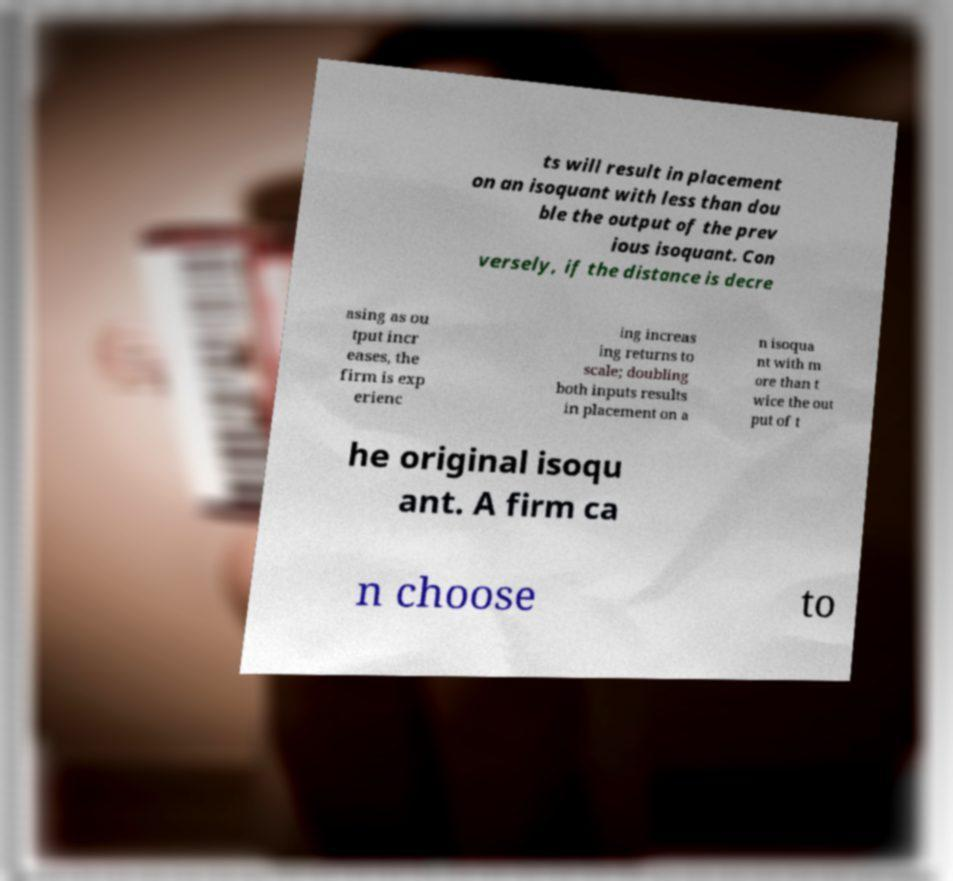There's text embedded in this image that I need extracted. Can you transcribe it verbatim? ts will result in placement on an isoquant with less than dou ble the output of the prev ious isoquant. Con versely, if the distance is decre asing as ou tput incr eases, the firm is exp erienc ing increas ing returns to scale; doubling both inputs results in placement on a n isoqua nt with m ore than t wice the out put of t he original isoqu ant. A firm ca n choose to 